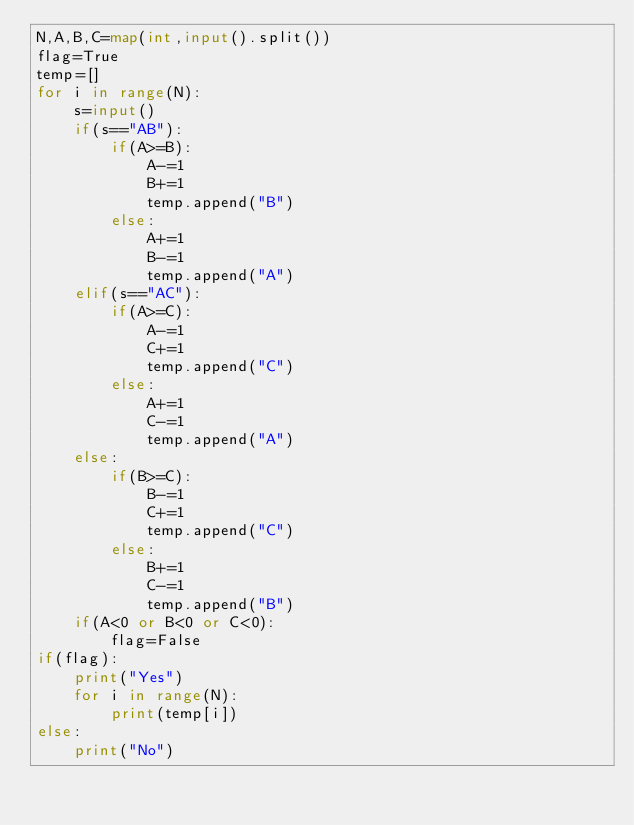Convert code to text. <code><loc_0><loc_0><loc_500><loc_500><_Python_>N,A,B,C=map(int,input().split())
flag=True
temp=[]
for i in range(N):
    s=input()
    if(s=="AB"):
        if(A>=B):
            A-=1
            B+=1
            temp.append("B")
        else:
            A+=1
            B-=1
            temp.append("A")
    elif(s=="AC"):
        if(A>=C):
            A-=1
            C+=1
            temp.append("C")
        else:
            A+=1
            C-=1
            temp.append("A")
    else:
        if(B>=C):
            B-=1
            C+=1
            temp.append("C")
        else:
            B+=1
            C-=1
            temp.append("B")
    if(A<0 or B<0 or C<0):
        flag=False
if(flag):
    print("Yes")
    for i in range(N):
        print(temp[i])
else:
    print("No")</code> 